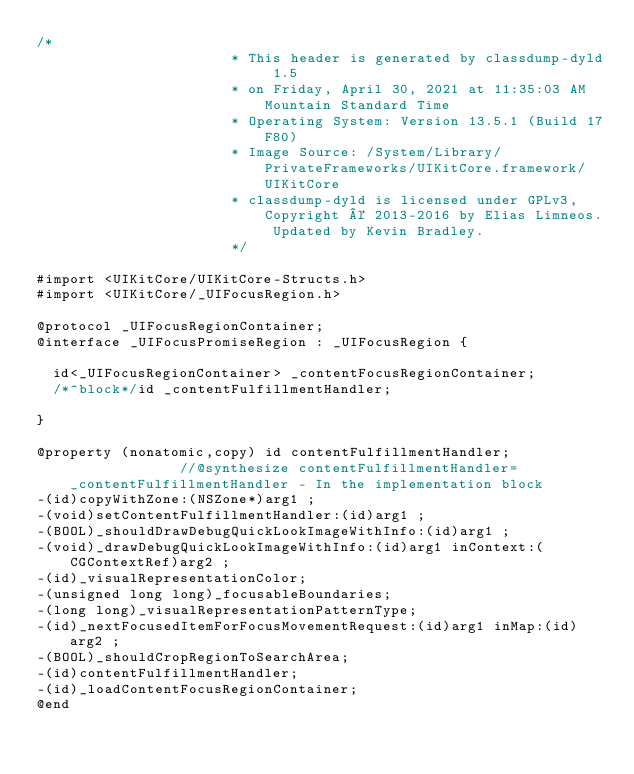Convert code to text. <code><loc_0><loc_0><loc_500><loc_500><_C_>/*
                       * This header is generated by classdump-dyld 1.5
                       * on Friday, April 30, 2021 at 11:35:03 AM Mountain Standard Time
                       * Operating System: Version 13.5.1 (Build 17F80)
                       * Image Source: /System/Library/PrivateFrameworks/UIKitCore.framework/UIKitCore
                       * classdump-dyld is licensed under GPLv3, Copyright © 2013-2016 by Elias Limneos. Updated by Kevin Bradley.
                       */

#import <UIKitCore/UIKitCore-Structs.h>
#import <UIKitCore/_UIFocusRegion.h>

@protocol _UIFocusRegionContainer;
@interface _UIFocusPromiseRegion : _UIFocusRegion {

	id<_UIFocusRegionContainer> _contentFocusRegionContainer;
	/*^block*/id _contentFulfillmentHandler;

}

@property (nonatomic,copy) id contentFulfillmentHandler;              //@synthesize contentFulfillmentHandler=_contentFulfillmentHandler - In the implementation block
-(id)copyWithZone:(NSZone*)arg1 ;
-(void)setContentFulfillmentHandler:(id)arg1 ;
-(BOOL)_shouldDrawDebugQuickLookImageWithInfo:(id)arg1 ;
-(void)_drawDebugQuickLookImageWithInfo:(id)arg1 inContext:(CGContextRef)arg2 ;
-(id)_visualRepresentationColor;
-(unsigned long long)_focusableBoundaries;
-(long long)_visualRepresentationPatternType;
-(id)_nextFocusedItemForFocusMovementRequest:(id)arg1 inMap:(id)arg2 ;
-(BOOL)_shouldCropRegionToSearchArea;
-(id)contentFulfillmentHandler;
-(id)_loadContentFocusRegionContainer;
@end

</code> 